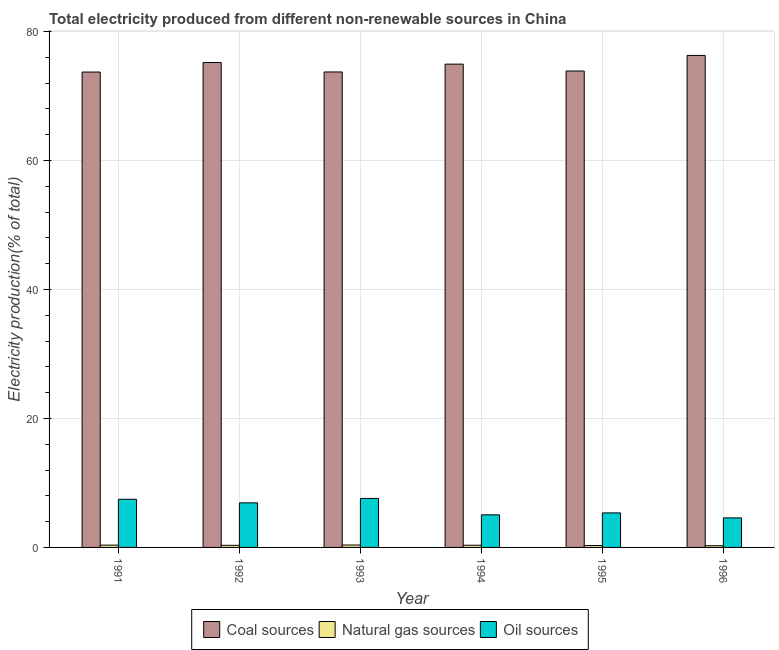How many different coloured bars are there?
Give a very brief answer. 3. How many groups of bars are there?
Make the answer very short. 6. Are the number of bars on each tick of the X-axis equal?
Offer a terse response. Yes. How many bars are there on the 2nd tick from the right?
Your response must be concise. 3. What is the label of the 4th group of bars from the left?
Provide a short and direct response. 1994. What is the percentage of electricity produced by coal in 1991?
Offer a terse response. 73.71. Across all years, what is the maximum percentage of electricity produced by coal?
Ensure brevity in your answer.  76.29. Across all years, what is the minimum percentage of electricity produced by coal?
Offer a very short reply. 73.71. In which year was the percentage of electricity produced by oil sources maximum?
Provide a short and direct response. 1993. What is the total percentage of electricity produced by natural gas in the graph?
Offer a very short reply. 1.95. What is the difference between the percentage of electricity produced by natural gas in 1992 and that in 1996?
Provide a short and direct response. 0.07. What is the difference between the percentage of electricity produced by oil sources in 1993 and the percentage of electricity produced by natural gas in 1991?
Provide a succinct answer. 0.13. What is the average percentage of electricity produced by oil sources per year?
Offer a very short reply. 6.16. In the year 1991, what is the difference between the percentage of electricity produced by oil sources and percentage of electricity produced by natural gas?
Ensure brevity in your answer.  0. In how many years, is the percentage of electricity produced by oil sources greater than 8 %?
Provide a short and direct response. 0. What is the ratio of the percentage of electricity produced by coal in 1993 to that in 1996?
Make the answer very short. 0.97. Is the difference between the percentage of electricity produced by natural gas in 1992 and 1995 greater than the difference between the percentage of electricity produced by oil sources in 1992 and 1995?
Give a very brief answer. No. What is the difference between the highest and the second highest percentage of electricity produced by oil sources?
Give a very brief answer. 0.13. What is the difference between the highest and the lowest percentage of electricity produced by coal?
Your answer should be compact. 2.58. Is the sum of the percentage of electricity produced by oil sources in 1993 and 1994 greater than the maximum percentage of electricity produced by coal across all years?
Make the answer very short. Yes. What does the 2nd bar from the left in 1994 represents?
Your response must be concise. Natural gas sources. What does the 3rd bar from the right in 1993 represents?
Provide a succinct answer. Coal sources. How many bars are there?
Your answer should be very brief. 18. How many years are there in the graph?
Ensure brevity in your answer.  6. What is the difference between two consecutive major ticks on the Y-axis?
Keep it short and to the point. 20. Are the values on the major ticks of Y-axis written in scientific E-notation?
Your answer should be very brief. No. Does the graph contain any zero values?
Provide a short and direct response. No. Where does the legend appear in the graph?
Make the answer very short. Bottom center. How many legend labels are there?
Your answer should be very brief. 3. How are the legend labels stacked?
Ensure brevity in your answer.  Horizontal. What is the title of the graph?
Give a very brief answer. Total electricity produced from different non-renewable sources in China. What is the label or title of the X-axis?
Keep it short and to the point. Year. What is the Electricity production(% of total) in Coal sources in 1991?
Provide a succinct answer. 73.71. What is the Electricity production(% of total) in Natural gas sources in 1991?
Keep it short and to the point. 0.36. What is the Electricity production(% of total) in Oil sources in 1991?
Make the answer very short. 7.47. What is the Electricity production(% of total) in Coal sources in 1992?
Keep it short and to the point. 75.19. What is the Electricity production(% of total) in Natural gas sources in 1992?
Keep it short and to the point. 0.33. What is the Electricity production(% of total) in Oil sources in 1992?
Provide a succinct answer. 6.91. What is the Electricity production(% of total) in Coal sources in 1993?
Offer a very short reply. 73.73. What is the Electricity production(% of total) of Natural gas sources in 1993?
Your answer should be very brief. 0.37. What is the Electricity production(% of total) in Oil sources in 1993?
Ensure brevity in your answer.  7.6. What is the Electricity production(% of total) in Coal sources in 1994?
Keep it short and to the point. 74.94. What is the Electricity production(% of total) of Natural gas sources in 1994?
Ensure brevity in your answer.  0.34. What is the Electricity production(% of total) of Oil sources in 1994?
Ensure brevity in your answer.  5.05. What is the Electricity production(% of total) of Coal sources in 1995?
Provide a short and direct response. 73.87. What is the Electricity production(% of total) of Natural gas sources in 1995?
Ensure brevity in your answer.  0.3. What is the Electricity production(% of total) of Oil sources in 1995?
Offer a terse response. 5.35. What is the Electricity production(% of total) in Coal sources in 1996?
Offer a terse response. 76.29. What is the Electricity production(% of total) in Natural gas sources in 1996?
Ensure brevity in your answer.  0.26. What is the Electricity production(% of total) in Oil sources in 1996?
Keep it short and to the point. 4.58. Across all years, what is the maximum Electricity production(% of total) of Coal sources?
Your answer should be very brief. 76.29. Across all years, what is the maximum Electricity production(% of total) in Natural gas sources?
Your answer should be very brief. 0.37. Across all years, what is the maximum Electricity production(% of total) in Oil sources?
Give a very brief answer. 7.6. Across all years, what is the minimum Electricity production(% of total) of Coal sources?
Give a very brief answer. 73.71. Across all years, what is the minimum Electricity production(% of total) of Natural gas sources?
Provide a short and direct response. 0.26. Across all years, what is the minimum Electricity production(% of total) in Oil sources?
Your answer should be compact. 4.58. What is the total Electricity production(% of total) in Coal sources in the graph?
Your answer should be compact. 447.72. What is the total Electricity production(% of total) in Natural gas sources in the graph?
Your response must be concise. 1.95. What is the total Electricity production(% of total) of Oil sources in the graph?
Provide a short and direct response. 36.97. What is the difference between the Electricity production(% of total) of Coal sources in 1991 and that in 1992?
Give a very brief answer. -1.48. What is the difference between the Electricity production(% of total) in Natural gas sources in 1991 and that in 1992?
Ensure brevity in your answer.  0.03. What is the difference between the Electricity production(% of total) of Oil sources in 1991 and that in 1992?
Your response must be concise. 0.56. What is the difference between the Electricity production(% of total) of Coal sources in 1991 and that in 1993?
Ensure brevity in your answer.  -0.02. What is the difference between the Electricity production(% of total) in Natural gas sources in 1991 and that in 1993?
Ensure brevity in your answer.  -0.01. What is the difference between the Electricity production(% of total) of Oil sources in 1991 and that in 1993?
Offer a terse response. -0.13. What is the difference between the Electricity production(% of total) of Coal sources in 1991 and that in 1994?
Make the answer very short. -1.23. What is the difference between the Electricity production(% of total) in Natural gas sources in 1991 and that in 1994?
Offer a very short reply. 0.02. What is the difference between the Electricity production(% of total) in Oil sources in 1991 and that in 1994?
Give a very brief answer. 2.41. What is the difference between the Electricity production(% of total) in Coal sources in 1991 and that in 1995?
Provide a short and direct response. -0.16. What is the difference between the Electricity production(% of total) in Natural gas sources in 1991 and that in 1995?
Provide a short and direct response. 0.06. What is the difference between the Electricity production(% of total) of Oil sources in 1991 and that in 1995?
Keep it short and to the point. 2.12. What is the difference between the Electricity production(% of total) of Coal sources in 1991 and that in 1996?
Make the answer very short. -2.58. What is the difference between the Electricity production(% of total) in Natural gas sources in 1991 and that in 1996?
Give a very brief answer. 0.1. What is the difference between the Electricity production(% of total) of Oil sources in 1991 and that in 1996?
Provide a short and direct response. 2.89. What is the difference between the Electricity production(% of total) in Coal sources in 1992 and that in 1993?
Your response must be concise. 1.46. What is the difference between the Electricity production(% of total) of Natural gas sources in 1992 and that in 1993?
Offer a terse response. -0.05. What is the difference between the Electricity production(% of total) of Oil sources in 1992 and that in 1993?
Your response must be concise. -0.69. What is the difference between the Electricity production(% of total) of Coal sources in 1992 and that in 1994?
Keep it short and to the point. 0.25. What is the difference between the Electricity production(% of total) of Natural gas sources in 1992 and that in 1994?
Make the answer very short. -0.01. What is the difference between the Electricity production(% of total) in Oil sources in 1992 and that in 1994?
Ensure brevity in your answer.  1.86. What is the difference between the Electricity production(% of total) in Coal sources in 1992 and that in 1995?
Give a very brief answer. 1.32. What is the difference between the Electricity production(% of total) of Natural gas sources in 1992 and that in 1995?
Keep it short and to the point. 0.03. What is the difference between the Electricity production(% of total) in Oil sources in 1992 and that in 1995?
Ensure brevity in your answer.  1.56. What is the difference between the Electricity production(% of total) in Coal sources in 1992 and that in 1996?
Offer a terse response. -1.1. What is the difference between the Electricity production(% of total) of Natural gas sources in 1992 and that in 1996?
Provide a succinct answer. 0.07. What is the difference between the Electricity production(% of total) of Oil sources in 1992 and that in 1996?
Ensure brevity in your answer.  2.33. What is the difference between the Electricity production(% of total) in Coal sources in 1993 and that in 1994?
Offer a terse response. -1.21. What is the difference between the Electricity production(% of total) in Natural gas sources in 1993 and that in 1994?
Your answer should be very brief. 0.03. What is the difference between the Electricity production(% of total) of Oil sources in 1993 and that in 1994?
Your answer should be compact. 2.54. What is the difference between the Electricity production(% of total) in Coal sources in 1993 and that in 1995?
Give a very brief answer. -0.15. What is the difference between the Electricity production(% of total) in Natural gas sources in 1993 and that in 1995?
Provide a short and direct response. 0.07. What is the difference between the Electricity production(% of total) in Oil sources in 1993 and that in 1995?
Ensure brevity in your answer.  2.24. What is the difference between the Electricity production(% of total) of Coal sources in 1993 and that in 1996?
Provide a succinct answer. -2.56. What is the difference between the Electricity production(% of total) of Natural gas sources in 1993 and that in 1996?
Offer a very short reply. 0.11. What is the difference between the Electricity production(% of total) of Oil sources in 1993 and that in 1996?
Provide a succinct answer. 3.02. What is the difference between the Electricity production(% of total) of Coal sources in 1994 and that in 1995?
Your response must be concise. 1.07. What is the difference between the Electricity production(% of total) in Natural gas sources in 1994 and that in 1995?
Make the answer very short. 0.04. What is the difference between the Electricity production(% of total) of Oil sources in 1994 and that in 1995?
Your response must be concise. -0.3. What is the difference between the Electricity production(% of total) in Coal sources in 1994 and that in 1996?
Offer a terse response. -1.35. What is the difference between the Electricity production(% of total) of Natural gas sources in 1994 and that in 1996?
Offer a very short reply. 0.08. What is the difference between the Electricity production(% of total) of Oil sources in 1994 and that in 1996?
Your response must be concise. 0.47. What is the difference between the Electricity production(% of total) of Coal sources in 1995 and that in 1996?
Offer a terse response. -2.42. What is the difference between the Electricity production(% of total) in Natural gas sources in 1995 and that in 1996?
Give a very brief answer. 0.04. What is the difference between the Electricity production(% of total) of Oil sources in 1995 and that in 1996?
Give a very brief answer. 0.77. What is the difference between the Electricity production(% of total) in Coal sources in 1991 and the Electricity production(% of total) in Natural gas sources in 1992?
Your answer should be compact. 73.38. What is the difference between the Electricity production(% of total) in Coal sources in 1991 and the Electricity production(% of total) in Oil sources in 1992?
Make the answer very short. 66.8. What is the difference between the Electricity production(% of total) in Natural gas sources in 1991 and the Electricity production(% of total) in Oil sources in 1992?
Offer a terse response. -6.55. What is the difference between the Electricity production(% of total) in Coal sources in 1991 and the Electricity production(% of total) in Natural gas sources in 1993?
Keep it short and to the point. 73.34. What is the difference between the Electricity production(% of total) in Coal sources in 1991 and the Electricity production(% of total) in Oil sources in 1993?
Give a very brief answer. 66.11. What is the difference between the Electricity production(% of total) in Natural gas sources in 1991 and the Electricity production(% of total) in Oil sources in 1993?
Keep it short and to the point. -7.24. What is the difference between the Electricity production(% of total) in Coal sources in 1991 and the Electricity production(% of total) in Natural gas sources in 1994?
Your answer should be compact. 73.37. What is the difference between the Electricity production(% of total) in Coal sources in 1991 and the Electricity production(% of total) in Oil sources in 1994?
Provide a succinct answer. 68.66. What is the difference between the Electricity production(% of total) of Natural gas sources in 1991 and the Electricity production(% of total) of Oil sources in 1994?
Ensure brevity in your answer.  -4.7. What is the difference between the Electricity production(% of total) in Coal sources in 1991 and the Electricity production(% of total) in Natural gas sources in 1995?
Provide a succinct answer. 73.41. What is the difference between the Electricity production(% of total) of Coal sources in 1991 and the Electricity production(% of total) of Oil sources in 1995?
Your answer should be compact. 68.36. What is the difference between the Electricity production(% of total) in Natural gas sources in 1991 and the Electricity production(% of total) in Oil sources in 1995?
Offer a terse response. -5. What is the difference between the Electricity production(% of total) of Coal sources in 1991 and the Electricity production(% of total) of Natural gas sources in 1996?
Make the answer very short. 73.45. What is the difference between the Electricity production(% of total) in Coal sources in 1991 and the Electricity production(% of total) in Oil sources in 1996?
Offer a very short reply. 69.13. What is the difference between the Electricity production(% of total) of Natural gas sources in 1991 and the Electricity production(% of total) of Oil sources in 1996?
Offer a terse response. -4.22. What is the difference between the Electricity production(% of total) of Coal sources in 1992 and the Electricity production(% of total) of Natural gas sources in 1993?
Offer a terse response. 74.82. What is the difference between the Electricity production(% of total) in Coal sources in 1992 and the Electricity production(% of total) in Oil sources in 1993?
Make the answer very short. 67.59. What is the difference between the Electricity production(% of total) in Natural gas sources in 1992 and the Electricity production(% of total) in Oil sources in 1993?
Provide a short and direct response. -7.27. What is the difference between the Electricity production(% of total) in Coal sources in 1992 and the Electricity production(% of total) in Natural gas sources in 1994?
Ensure brevity in your answer.  74.85. What is the difference between the Electricity production(% of total) of Coal sources in 1992 and the Electricity production(% of total) of Oil sources in 1994?
Your answer should be very brief. 70.14. What is the difference between the Electricity production(% of total) in Natural gas sources in 1992 and the Electricity production(% of total) in Oil sources in 1994?
Offer a terse response. -4.73. What is the difference between the Electricity production(% of total) of Coal sources in 1992 and the Electricity production(% of total) of Natural gas sources in 1995?
Ensure brevity in your answer.  74.89. What is the difference between the Electricity production(% of total) of Coal sources in 1992 and the Electricity production(% of total) of Oil sources in 1995?
Your response must be concise. 69.84. What is the difference between the Electricity production(% of total) in Natural gas sources in 1992 and the Electricity production(% of total) in Oil sources in 1995?
Make the answer very short. -5.03. What is the difference between the Electricity production(% of total) in Coal sources in 1992 and the Electricity production(% of total) in Natural gas sources in 1996?
Your answer should be very brief. 74.93. What is the difference between the Electricity production(% of total) of Coal sources in 1992 and the Electricity production(% of total) of Oil sources in 1996?
Your response must be concise. 70.61. What is the difference between the Electricity production(% of total) in Natural gas sources in 1992 and the Electricity production(% of total) in Oil sources in 1996?
Make the answer very short. -4.25. What is the difference between the Electricity production(% of total) of Coal sources in 1993 and the Electricity production(% of total) of Natural gas sources in 1994?
Your answer should be compact. 73.39. What is the difference between the Electricity production(% of total) in Coal sources in 1993 and the Electricity production(% of total) in Oil sources in 1994?
Your answer should be compact. 68.67. What is the difference between the Electricity production(% of total) in Natural gas sources in 1993 and the Electricity production(% of total) in Oil sources in 1994?
Provide a short and direct response. -4.68. What is the difference between the Electricity production(% of total) of Coal sources in 1993 and the Electricity production(% of total) of Natural gas sources in 1995?
Your response must be concise. 73.43. What is the difference between the Electricity production(% of total) of Coal sources in 1993 and the Electricity production(% of total) of Oil sources in 1995?
Your answer should be very brief. 68.37. What is the difference between the Electricity production(% of total) of Natural gas sources in 1993 and the Electricity production(% of total) of Oil sources in 1995?
Give a very brief answer. -4.98. What is the difference between the Electricity production(% of total) in Coal sources in 1993 and the Electricity production(% of total) in Natural gas sources in 1996?
Keep it short and to the point. 73.46. What is the difference between the Electricity production(% of total) in Coal sources in 1993 and the Electricity production(% of total) in Oil sources in 1996?
Offer a terse response. 69.15. What is the difference between the Electricity production(% of total) in Natural gas sources in 1993 and the Electricity production(% of total) in Oil sources in 1996?
Make the answer very short. -4.21. What is the difference between the Electricity production(% of total) of Coal sources in 1994 and the Electricity production(% of total) of Natural gas sources in 1995?
Your response must be concise. 74.64. What is the difference between the Electricity production(% of total) of Coal sources in 1994 and the Electricity production(% of total) of Oil sources in 1995?
Your response must be concise. 69.59. What is the difference between the Electricity production(% of total) of Natural gas sources in 1994 and the Electricity production(% of total) of Oil sources in 1995?
Provide a succinct answer. -5.01. What is the difference between the Electricity production(% of total) in Coal sources in 1994 and the Electricity production(% of total) in Natural gas sources in 1996?
Offer a terse response. 74.68. What is the difference between the Electricity production(% of total) of Coal sources in 1994 and the Electricity production(% of total) of Oil sources in 1996?
Your response must be concise. 70.36. What is the difference between the Electricity production(% of total) in Natural gas sources in 1994 and the Electricity production(% of total) in Oil sources in 1996?
Make the answer very short. -4.24. What is the difference between the Electricity production(% of total) of Coal sources in 1995 and the Electricity production(% of total) of Natural gas sources in 1996?
Offer a terse response. 73.61. What is the difference between the Electricity production(% of total) in Coal sources in 1995 and the Electricity production(% of total) in Oil sources in 1996?
Provide a succinct answer. 69.29. What is the difference between the Electricity production(% of total) in Natural gas sources in 1995 and the Electricity production(% of total) in Oil sources in 1996?
Make the answer very short. -4.28. What is the average Electricity production(% of total) in Coal sources per year?
Ensure brevity in your answer.  74.62. What is the average Electricity production(% of total) in Natural gas sources per year?
Your answer should be compact. 0.33. What is the average Electricity production(% of total) of Oil sources per year?
Ensure brevity in your answer.  6.16. In the year 1991, what is the difference between the Electricity production(% of total) in Coal sources and Electricity production(% of total) in Natural gas sources?
Your response must be concise. 73.35. In the year 1991, what is the difference between the Electricity production(% of total) in Coal sources and Electricity production(% of total) in Oil sources?
Your answer should be very brief. 66.24. In the year 1991, what is the difference between the Electricity production(% of total) in Natural gas sources and Electricity production(% of total) in Oil sources?
Offer a very short reply. -7.11. In the year 1992, what is the difference between the Electricity production(% of total) of Coal sources and Electricity production(% of total) of Natural gas sources?
Your answer should be compact. 74.86. In the year 1992, what is the difference between the Electricity production(% of total) of Coal sources and Electricity production(% of total) of Oil sources?
Provide a short and direct response. 68.28. In the year 1992, what is the difference between the Electricity production(% of total) in Natural gas sources and Electricity production(% of total) in Oil sources?
Ensure brevity in your answer.  -6.59. In the year 1993, what is the difference between the Electricity production(% of total) in Coal sources and Electricity production(% of total) in Natural gas sources?
Provide a succinct answer. 73.35. In the year 1993, what is the difference between the Electricity production(% of total) of Coal sources and Electricity production(% of total) of Oil sources?
Your response must be concise. 66.13. In the year 1993, what is the difference between the Electricity production(% of total) in Natural gas sources and Electricity production(% of total) in Oil sources?
Offer a terse response. -7.23. In the year 1994, what is the difference between the Electricity production(% of total) in Coal sources and Electricity production(% of total) in Natural gas sources?
Provide a short and direct response. 74.6. In the year 1994, what is the difference between the Electricity production(% of total) of Coal sources and Electricity production(% of total) of Oil sources?
Offer a terse response. 69.89. In the year 1994, what is the difference between the Electricity production(% of total) in Natural gas sources and Electricity production(% of total) in Oil sources?
Offer a very short reply. -4.71. In the year 1995, what is the difference between the Electricity production(% of total) of Coal sources and Electricity production(% of total) of Natural gas sources?
Keep it short and to the point. 73.58. In the year 1995, what is the difference between the Electricity production(% of total) in Coal sources and Electricity production(% of total) in Oil sources?
Give a very brief answer. 68.52. In the year 1995, what is the difference between the Electricity production(% of total) of Natural gas sources and Electricity production(% of total) of Oil sources?
Provide a succinct answer. -5.06. In the year 1996, what is the difference between the Electricity production(% of total) of Coal sources and Electricity production(% of total) of Natural gas sources?
Keep it short and to the point. 76.03. In the year 1996, what is the difference between the Electricity production(% of total) of Coal sources and Electricity production(% of total) of Oil sources?
Keep it short and to the point. 71.71. In the year 1996, what is the difference between the Electricity production(% of total) in Natural gas sources and Electricity production(% of total) in Oil sources?
Your answer should be compact. -4.32. What is the ratio of the Electricity production(% of total) in Coal sources in 1991 to that in 1992?
Provide a succinct answer. 0.98. What is the ratio of the Electricity production(% of total) in Natural gas sources in 1991 to that in 1992?
Provide a succinct answer. 1.1. What is the ratio of the Electricity production(% of total) of Oil sources in 1991 to that in 1992?
Your answer should be compact. 1.08. What is the ratio of the Electricity production(% of total) in Natural gas sources in 1991 to that in 1993?
Keep it short and to the point. 0.96. What is the ratio of the Electricity production(% of total) in Coal sources in 1991 to that in 1994?
Provide a short and direct response. 0.98. What is the ratio of the Electricity production(% of total) in Natural gas sources in 1991 to that in 1994?
Provide a short and direct response. 1.05. What is the ratio of the Electricity production(% of total) of Oil sources in 1991 to that in 1994?
Your answer should be very brief. 1.48. What is the ratio of the Electricity production(% of total) of Natural gas sources in 1991 to that in 1995?
Offer a very short reply. 1.21. What is the ratio of the Electricity production(% of total) of Oil sources in 1991 to that in 1995?
Keep it short and to the point. 1.4. What is the ratio of the Electricity production(% of total) in Coal sources in 1991 to that in 1996?
Ensure brevity in your answer.  0.97. What is the ratio of the Electricity production(% of total) of Natural gas sources in 1991 to that in 1996?
Your answer should be compact. 1.37. What is the ratio of the Electricity production(% of total) of Oil sources in 1991 to that in 1996?
Provide a short and direct response. 1.63. What is the ratio of the Electricity production(% of total) of Coal sources in 1992 to that in 1993?
Offer a very short reply. 1.02. What is the ratio of the Electricity production(% of total) in Natural gas sources in 1992 to that in 1993?
Offer a very short reply. 0.88. What is the ratio of the Electricity production(% of total) of Oil sources in 1992 to that in 1993?
Give a very brief answer. 0.91. What is the ratio of the Electricity production(% of total) of Natural gas sources in 1992 to that in 1994?
Keep it short and to the point. 0.96. What is the ratio of the Electricity production(% of total) in Oil sources in 1992 to that in 1994?
Offer a terse response. 1.37. What is the ratio of the Electricity production(% of total) in Coal sources in 1992 to that in 1995?
Keep it short and to the point. 1.02. What is the ratio of the Electricity production(% of total) of Natural gas sources in 1992 to that in 1995?
Provide a succinct answer. 1.1. What is the ratio of the Electricity production(% of total) in Oil sources in 1992 to that in 1995?
Give a very brief answer. 1.29. What is the ratio of the Electricity production(% of total) of Coal sources in 1992 to that in 1996?
Ensure brevity in your answer.  0.99. What is the ratio of the Electricity production(% of total) in Natural gas sources in 1992 to that in 1996?
Ensure brevity in your answer.  1.25. What is the ratio of the Electricity production(% of total) of Oil sources in 1992 to that in 1996?
Provide a succinct answer. 1.51. What is the ratio of the Electricity production(% of total) of Coal sources in 1993 to that in 1994?
Give a very brief answer. 0.98. What is the ratio of the Electricity production(% of total) of Natural gas sources in 1993 to that in 1994?
Make the answer very short. 1.1. What is the ratio of the Electricity production(% of total) in Oil sources in 1993 to that in 1994?
Keep it short and to the point. 1.5. What is the ratio of the Electricity production(% of total) of Natural gas sources in 1993 to that in 1995?
Provide a succinct answer. 1.25. What is the ratio of the Electricity production(% of total) of Oil sources in 1993 to that in 1995?
Your answer should be compact. 1.42. What is the ratio of the Electricity production(% of total) in Coal sources in 1993 to that in 1996?
Give a very brief answer. 0.97. What is the ratio of the Electricity production(% of total) of Natural gas sources in 1993 to that in 1996?
Ensure brevity in your answer.  1.42. What is the ratio of the Electricity production(% of total) in Oil sources in 1993 to that in 1996?
Offer a very short reply. 1.66. What is the ratio of the Electricity production(% of total) in Coal sources in 1994 to that in 1995?
Your answer should be very brief. 1.01. What is the ratio of the Electricity production(% of total) of Natural gas sources in 1994 to that in 1995?
Your response must be concise. 1.14. What is the ratio of the Electricity production(% of total) of Oil sources in 1994 to that in 1995?
Ensure brevity in your answer.  0.94. What is the ratio of the Electricity production(% of total) in Coal sources in 1994 to that in 1996?
Offer a terse response. 0.98. What is the ratio of the Electricity production(% of total) of Natural gas sources in 1994 to that in 1996?
Offer a terse response. 1.3. What is the ratio of the Electricity production(% of total) in Oil sources in 1994 to that in 1996?
Your response must be concise. 1.1. What is the ratio of the Electricity production(% of total) in Coal sources in 1995 to that in 1996?
Give a very brief answer. 0.97. What is the ratio of the Electricity production(% of total) in Natural gas sources in 1995 to that in 1996?
Your answer should be very brief. 1.14. What is the ratio of the Electricity production(% of total) in Oil sources in 1995 to that in 1996?
Give a very brief answer. 1.17. What is the difference between the highest and the second highest Electricity production(% of total) in Coal sources?
Offer a terse response. 1.1. What is the difference between the highest and the second highest Electricity production(% of total) of Natural gas sources?
Offer a very short reply. 0.01. What is the difference between the highest and the second highest Electricity production(% of total) of Oil sources?
Offer a terse response. 0.13. What is the difference between the highest and the lowest Electricity production(% of total) in Coal sources?
Provide a succinct answer. 2.58. What is the difference between the highest and the lowest Electricity production(% of total) of Natural gas sources?
Offer a very short reply. 0.11. What is the difference between the highest and the lowest Electricity production(% of total) in Oil sources?
Make the answer very short. 3.02. 